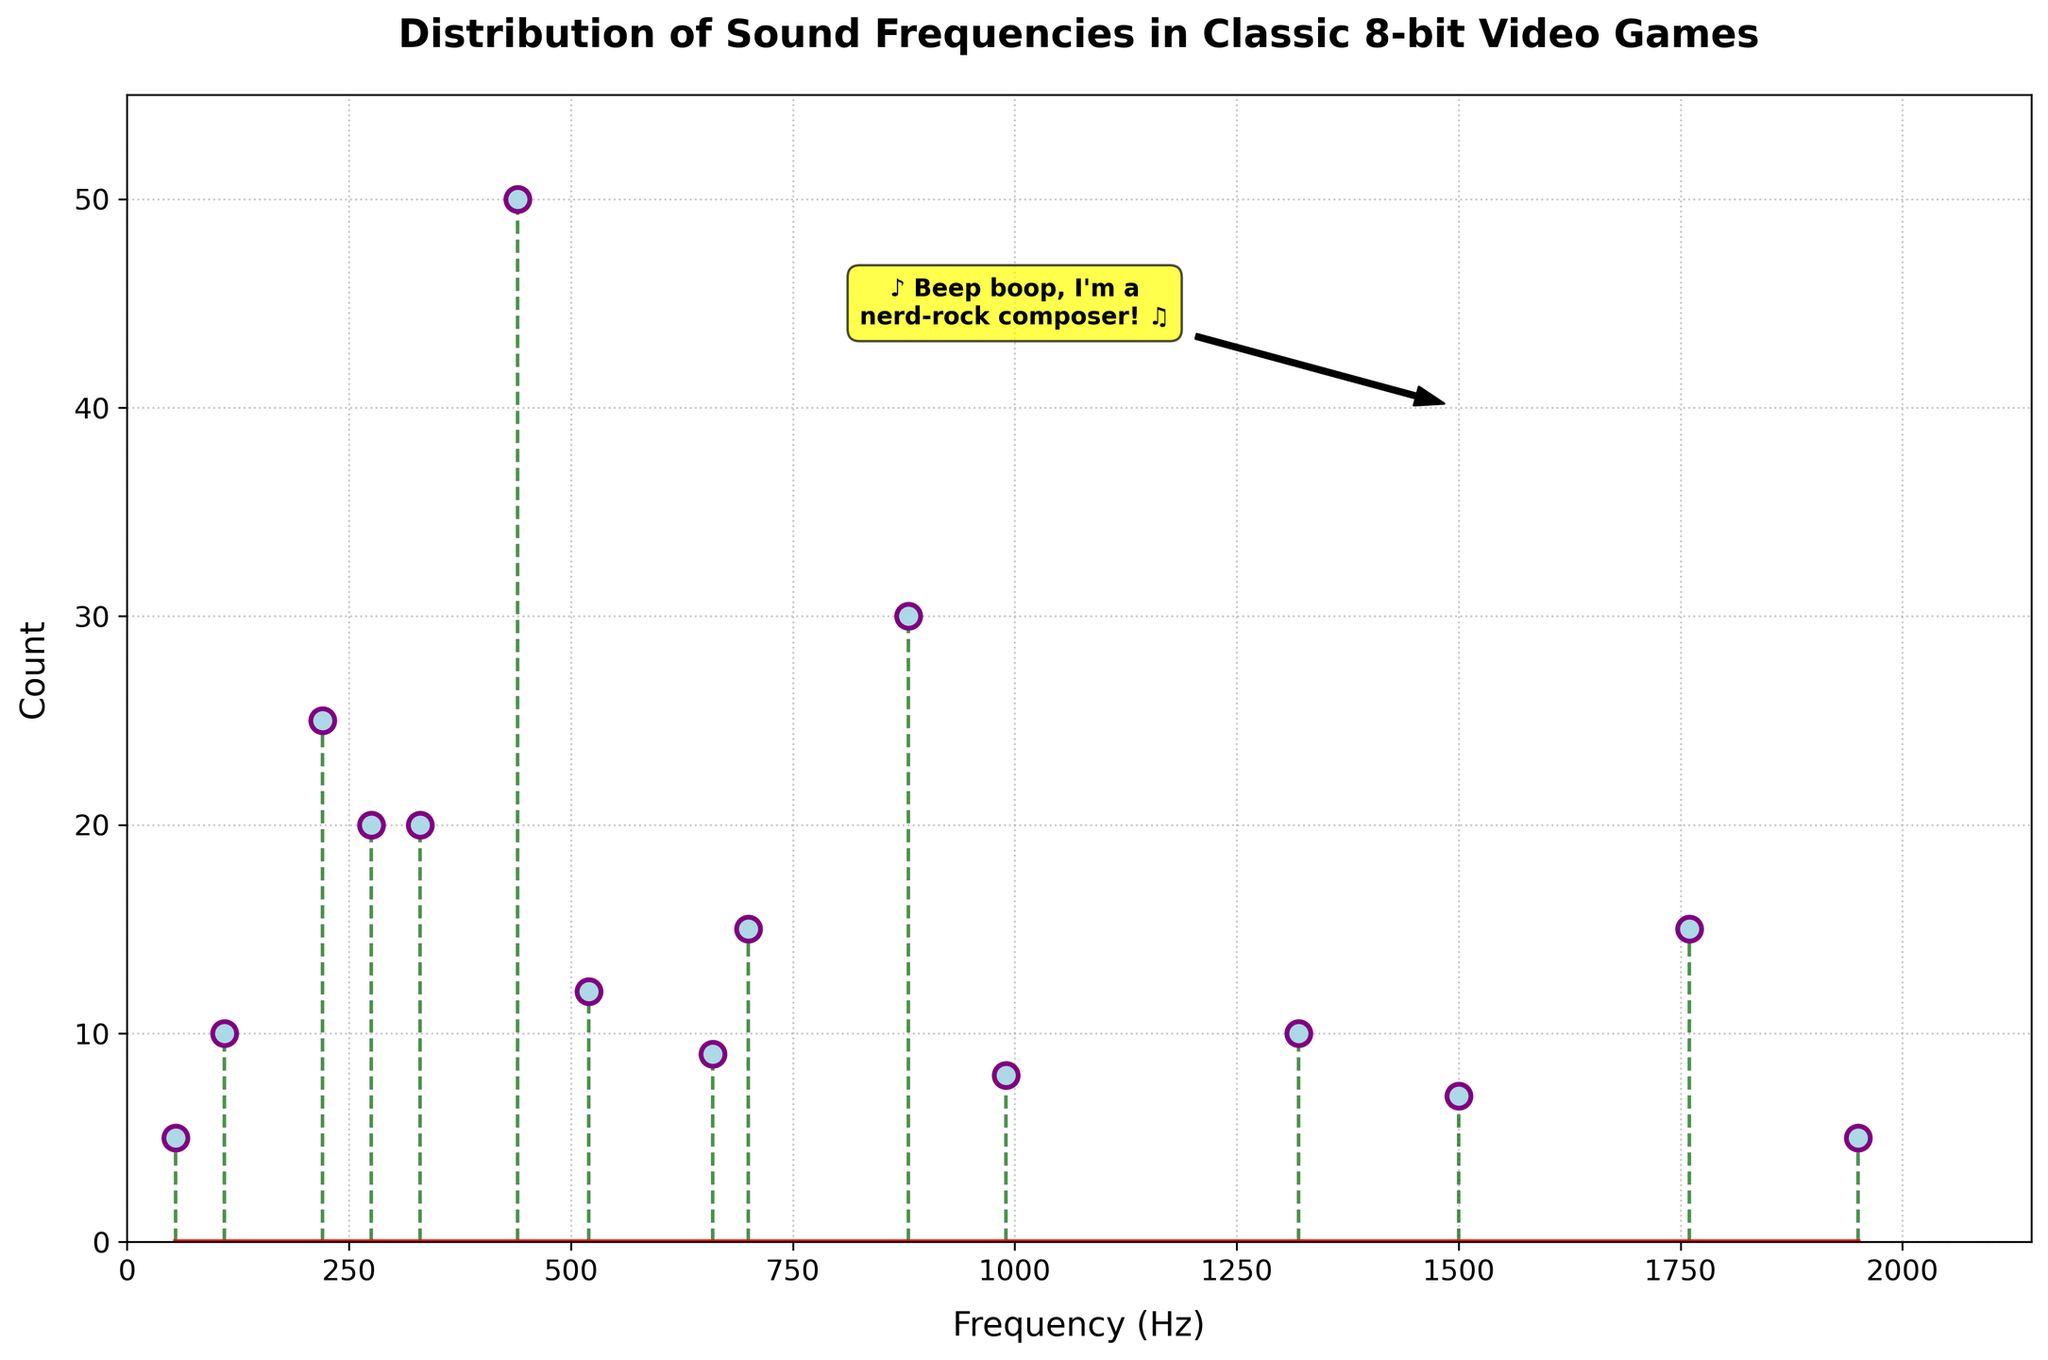What is the title of the plot? The title is found at the top of the plot and it provides a brief description of the content. In this plot, it reads "Distribution of Sound Frequencies in Classic 8-bit Video Games".
Answer: Distribution of Sound Frequencies in Classic 8-bit Video Games What is the maximum frequency shown on the x-axis? The x-axis represents the frequencies in Hertz (Hz). To find the maximum frequency, we look at the rightmost limit of the x-axis. In this plot, it is slightly above the maximum data point of 1950 Hz.
Answer: 2200 Hz How many frequencies have counts greater than 10? We need to count the number of vertical lines (stems) whose lengths (counts) are above 10. Here, the frequencies 440, 880, 220, 330, and 520 have counts greater than 10.
Answer: 5 Which frequency has the highest count of usage? The highest count can be identified by the longest vertical stem. In this plot, the frequency of 440 Hz has the longest stem corresponding to a count of 50.
Answer: 440 Hz What is the total count of frequencies of 220 Hz and 330 Hz combined? Add the counts for the frequencies 220 Hz and 330 Hz. The count for 220 Hz is 25 and for 330 Hz is 20, resulting in a total of 45.
Answer: 45 Which frequency has the least usage, and what is its count? The least usage corresponds to the shortest vertical stem. In this plot, both 55 Hz and 1950 Hz have the shortest stems, with each having a count of 5.
Answer: 55 Hz and 1950 Hz, 5 Are there more frequencies below 500 Hz or above 500 Hz? Count the number of frequencies below 500 Hz and compare it to those above 500 Hz. Below 500 Hz, counts are for 55, 110, 220, 275, and 330 (5 frequencies). Above 500 Hz, counts are for 520, 660, 700, 880, 990, 1320, 1500, 1760, 1950 (9 frequencies).
Answer: More above 500 Hz What is the range of frequencies shown in the plot? The range is the difference between the maximum and minimum frequencies. The maximum frequency is 1950 Hz, and the minimum is 55 Hz. So, the range is 1950 - 55 = 1895 Hz.
Answer: 1895 Hz Which frequency between 1000 Hz and 2000 Hz has the highest count? Within the range of 1000 Hz to 2000 Hz, we look for the highest count. The highest stem in this range corresponds to 1760 Hz with a count of 15.
Answer: 1760 Hz How many data points are at frequencies above 1000 Hz? Count the number of frequencies above 1000 Hz. These frequencies are 1320, 1500, 1760, and 1950, resulting in 4 data points.
Answer: 4 